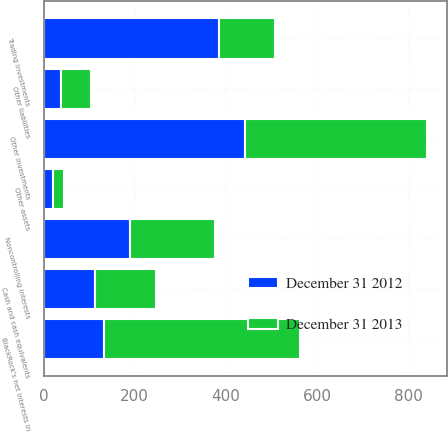<chart> <loc_0><loc_0><loc_500><loc_500><stacked_bar_chart><ecel><fcel>Cash and cash equivalents<fcel>Trading investments<fcel>Other investments<fcel>Other assets<fcel>Other liabilities<fcel>Noncontrolling interests<fcel>BlackRock's net interests in<nl><fcel>December 31 2012<fcel>114<fcel>385<fcel>441<fcel>20<fcel>39<fcel>189<fcel>133<nl><fcel>December 31 2013<fcel>133<fcel>123<fcel>401<fcel>25<fcel>65<fcel>187<fcel>430<nl></chart> 